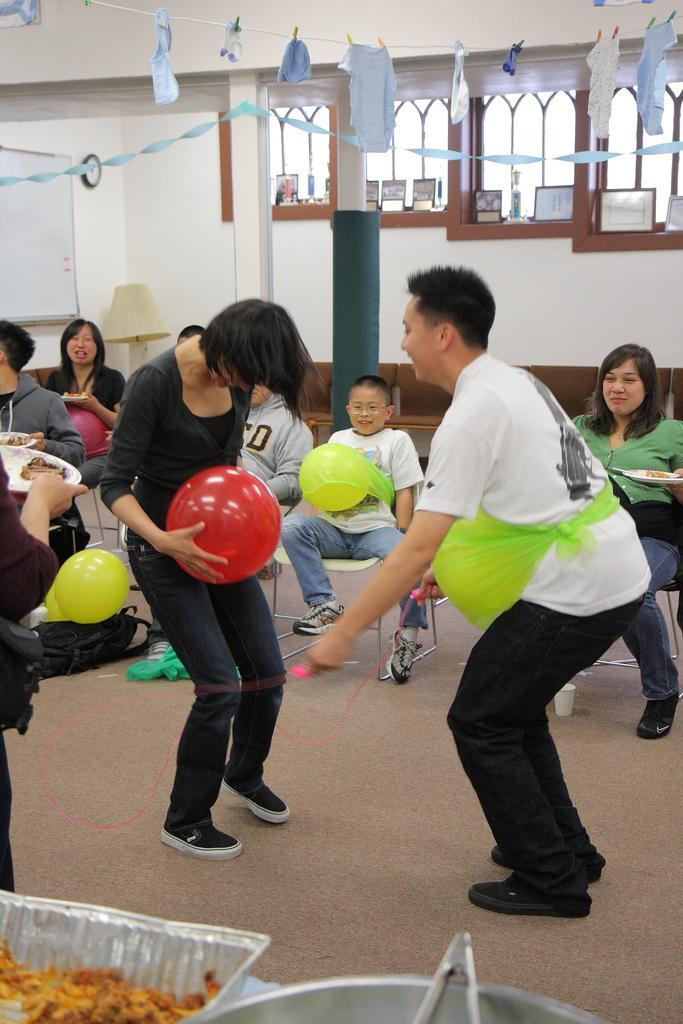Can you describe this image briefly? In this image I can see group of people some are standing and some are sitting. The person in front holding red color balloon wearing black color dress and the person at right wearing white shirt, black pant. Background I can see wall in white color and few windows. 